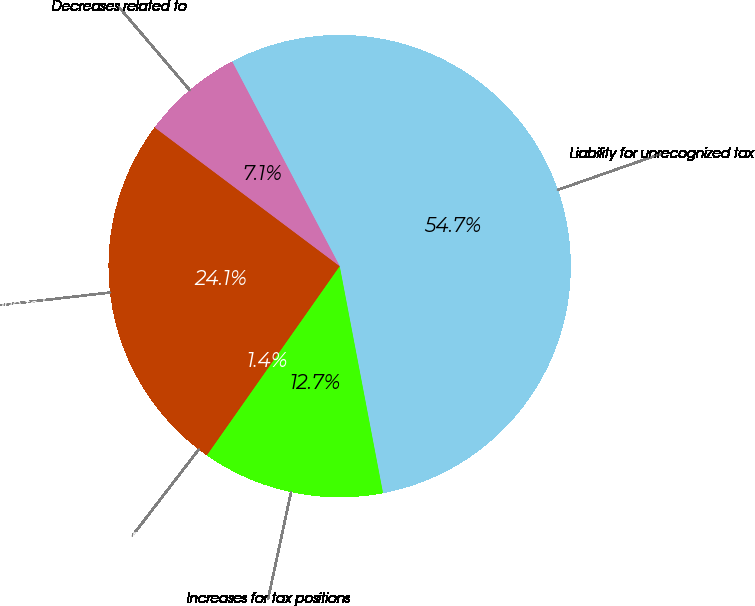Convert chart to OTSL. <chart><loc_0><loc_0><loc_500><loc_500><pie_chart><fcel>Liability for unrecognized tax<fcel>Increases for tax positions<fcel>Decreases for tax positions<fcel>Reductions due to lapsed<fcel>Decreases related to<nl><fcel>54.71%<fcel>12.75%<fcel>1.37%<fcel>24.13%<fcel>7.06%<nl></chart> 